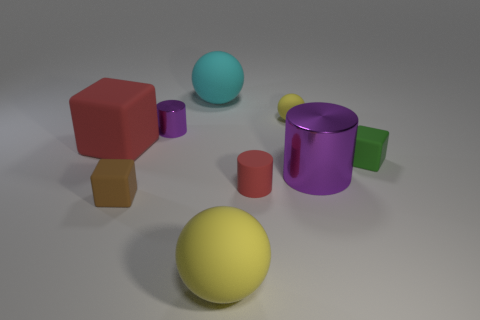There is a small block on the right side of the small brown matte cube; are there any shiny things that are in front of it? Directly in front of the small brown matte cube, there do not appear to be shiny objects, as the objects there have matte finishes. However, there is a reflective purple cylinder with a glossy surface positioned to the front left relative to the cube which may be considered shiny. 